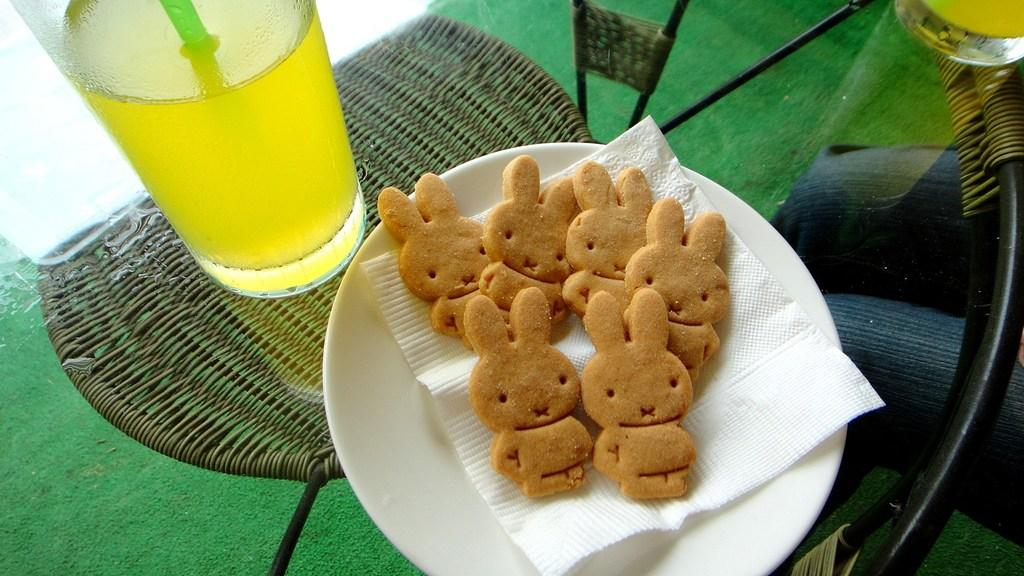What type of disposable item is visible in the image? There is a tissue paper in the image. What is on the plate that is visible in the image? There is food on a plate in the image. What type of tableware is present on the table in the image? There are glasses on the table in the image. Can you describe the person in the image? There is a person in the image, but no specific details about their appearance or actions are provided. What type of car is visible in the image? There is no car present in the image. What process is being carried out by the goose in the image? There is no goose present in the image. 